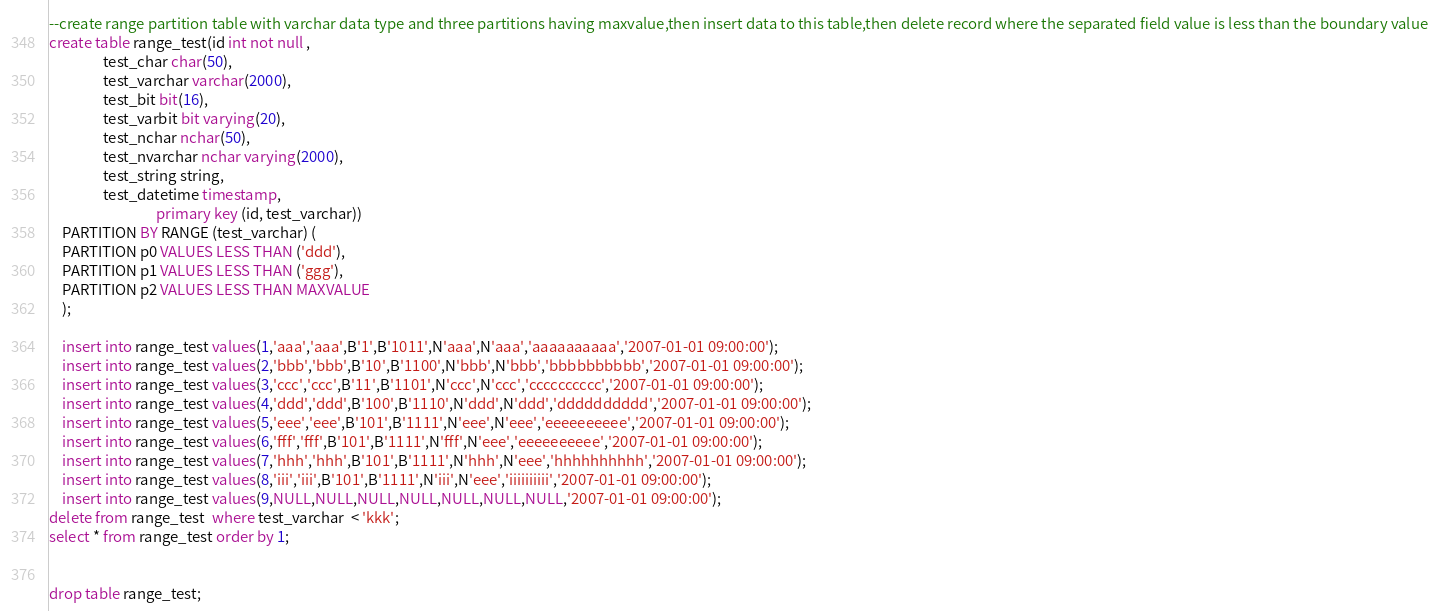Convert code to text. <code><loc_0><loc_0><loc_500><loc_500><_SQL_>--create range partition table with varchar data type and three partitions having maxvalue,then insert data to this table,then delete record where the separated field value is less than the boundary value
create table range_test(id int not null ,
				test_char char(50),
				test_varchar varchar(2000),
				test_bit bit(16),
				test_varbit bit varying(20),
				test_nchar nchar(50),
				test_nvarchar nchar varying(2000),
				test_string string,
				test_datetime timestamp,
                                primary key (id, test_varchar))
	PARTITION BY RANGE (test_varchar) (
	PARTITION p0 VALUES LESS THAN ('ddd'),
	PARTITION p1 VALUES LESS THAN ('ggg'),
	PARTITION p2 VALUES LESS THAN MAXVALUE
	);

	insert into range_test values(1,'aaa','aaa',B'1',B'1011',N'aaa',N'aaa','aaaaaaaaaa','2007-01-01 09:00:00');
	insert into range_test values(2,'bbb','bbb',B'10',B'1100',N'bbb',N'bbb','bbbbbbbbbb','2007-01-01 09:00:00');
	insert into range_test values(3,'ccc','ccc',B'11',B'1101',N'ccc',N'ccc','cccccccccc','2007-01-01 09:00:00');
	insert into range_test values(4,'ddd','ddd',B'100',B'1110',N'ddd',N'ddd','dddddddddd','2007-01-01 09:00:00');
	insert into range_test values(5,'eee','eee',B'101',B'1111',N'eee',N'eee','eeeeeeeeee','2007-01-01 09:00:00');
	insert into range_test values(6,'fff','fff',B'101',B'1111',N'fff',N'eee','eeeeeeeeee','2007-01-01 09:00:00');
	insert into range_test values(7,'hhh','hhh',B'101',B'1111',N'hhh',N'eee','hhhhhhhhhh','2007-01-01 09:00:00');
	insert into range_test values(8,'iii','iii',B'101',B'1111',N'iii',N'eee','iiiiiiiiii','2007-01-01 09:00:00');
	insert into range_test values(9,NULL,NULL,NULL,NULL,NULL,NULL,NULL,'2007-01-01 09:00:00');
delete from range_test  where test_varchar  < 'kkk';
select * from range_test order by 1;


drop table range_test;
</code> 